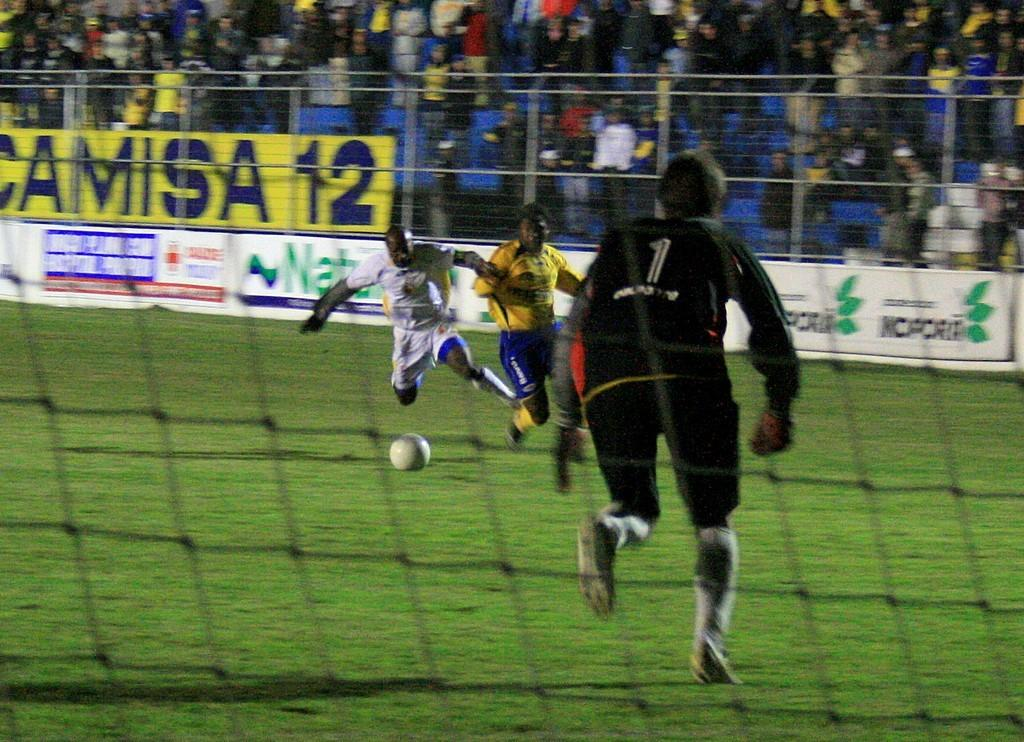<image>
Provide a brief description of the given image. Men are playing soccer on a field and one has the number 1 on his jersey. 